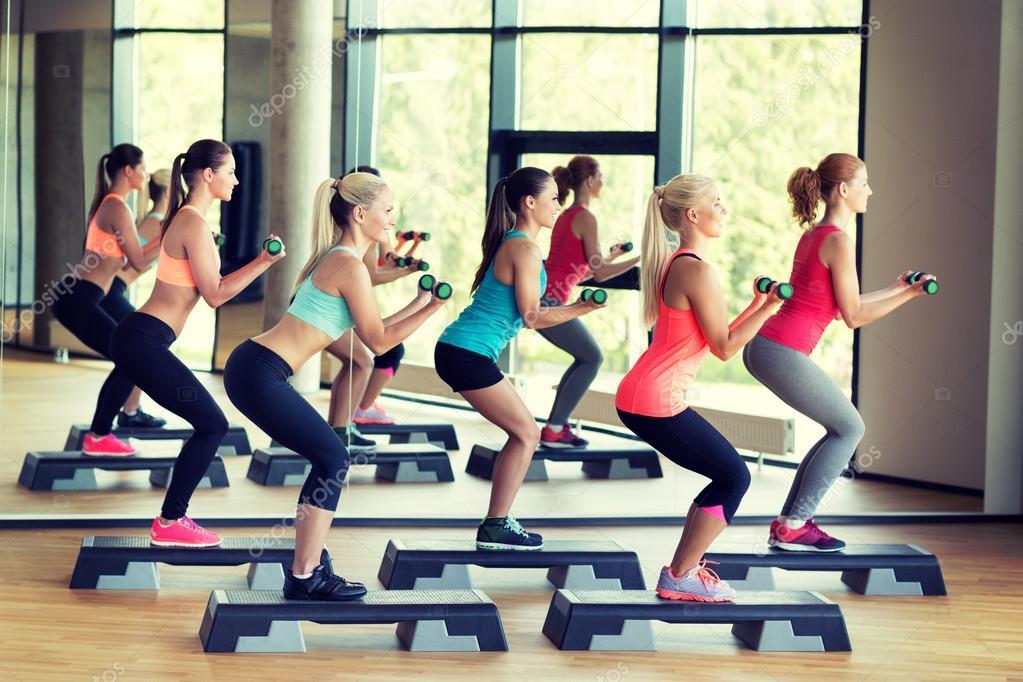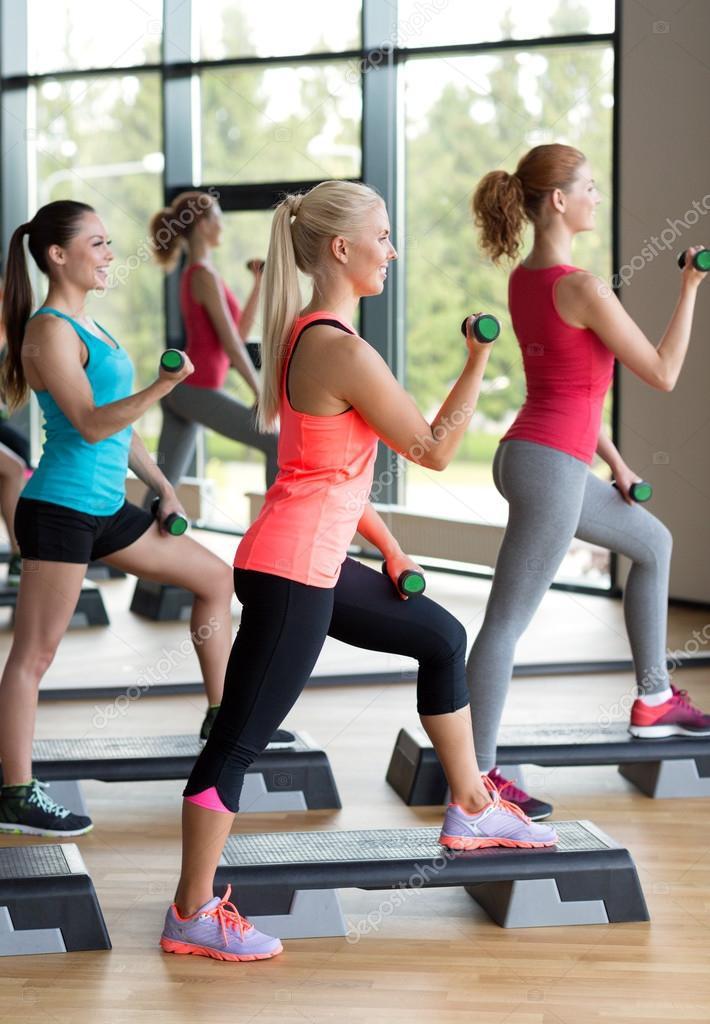The first image is the image on the left, the second image is the image on the right. Given the left and right images, does the statement "One image shows a workout with feet flat on the floor and hands holding dumbbells in front of the body, and the other image shows a similar workout with hands holding dumbbells out to the side." hold true? Answer yes or no. No. The first image is the image on the left, the second image is the image on the right. Assess this claim about the two images: "At least five women are stepping on a workout step with one foot.". Correct or not? Answer yes or no. Yes. 